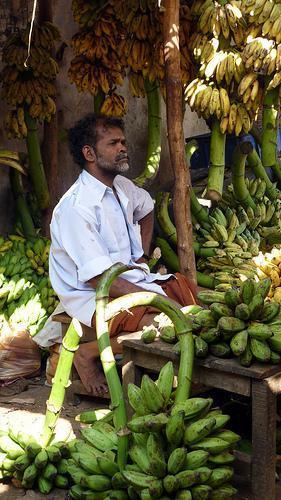How many people are in the picture?
Give a very brief answer. 1. 